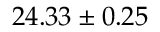<formula> <loc_0><loc_0><loc_500><loc_500>2 4 . 3 3 \pm 0 . 2 5</formula> 